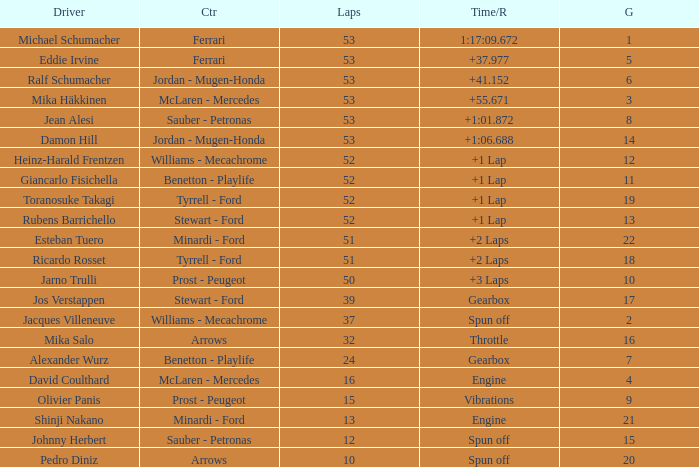Parse the full table. {'header': ['Driver', 'Ctr', 'Laps', 'Time/R', 'G'], 'rows': [['Michael Schumacher', 'Ferrari', '53', '1:17:09.672', '1'], ['Eddie Irvine', 'Ferrari', '53', '+37.977', '5'], ['Ralf Schumacher', 'Jordan - Mugen-Honda', '53', '+41.152', '6'], ['Mika Häkkinen', 'McLaren - Mercedes', '53', '+55.671', '3'], ['Jean Alesi', 'Sauber - Petronas', '53', '+1:01.872', '8'], ['Damon Hill', 'Jordan - Mugen-Honda', '53', '+1:06.688', '14'], ['Heinz-Harald Frentzen', 'Williams - Mecachrome', '52', '+1 Lap', '12'], ['Giancarlo Fisichella', 'Benetton - Playlife', '52', '+1 Lap', '11'], ['Toranosuke Takagi', 'Tyrrell - Ford', '52', '+1 Lap', '19'], ['Rubens Barrichello', 'Stewart - Ford', '52', '+1 Lap', '13'], ['Esteban Tuero', 'Minardi - Ford', '51', '+2 Laps', '22'], ['Ricardo Rosset', 'Tyrrell - Ford', '51', '+2 Laps', '18'], ['Jarno Trulli', 'Prost - Peugeot', '50', '+3 Laps', '10'], ['Jos Verstappen', 'Stewart - Ford', '39', 'Gearbox', '17'], ['Jacques Villeneuve', 'Williams - Mecachrome', '37', 'Spun off', '2'], ['Mika Salo', 'Arrows', '32', 'Throttle', '16'], ['Alexander Wurz', 'Benetton - Playlife', '24', 'Gearbox', '7'], ['David Coulthard', 'McLaren - Mercedes', '16', 'Engine', '4'], ['Olivier Panis', 'Prost - Peugeot', '15', 'Vibrations', '9'], ['Shinji Nakano', 'Minardi - Ford', '13', 'Engine', '21'], ['Johnny Herbert', 'Sauber - Petronas', '12', 'Spun off', '15'], ['Pedro Diniz', 'Arrows', '10', 'Spun off', '20']]} What is the high lap total for pedro diniz? 10.0. 